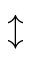<formula> <loc_0><loc_0><loc_500><loc_500>\updownarrow</formula> 